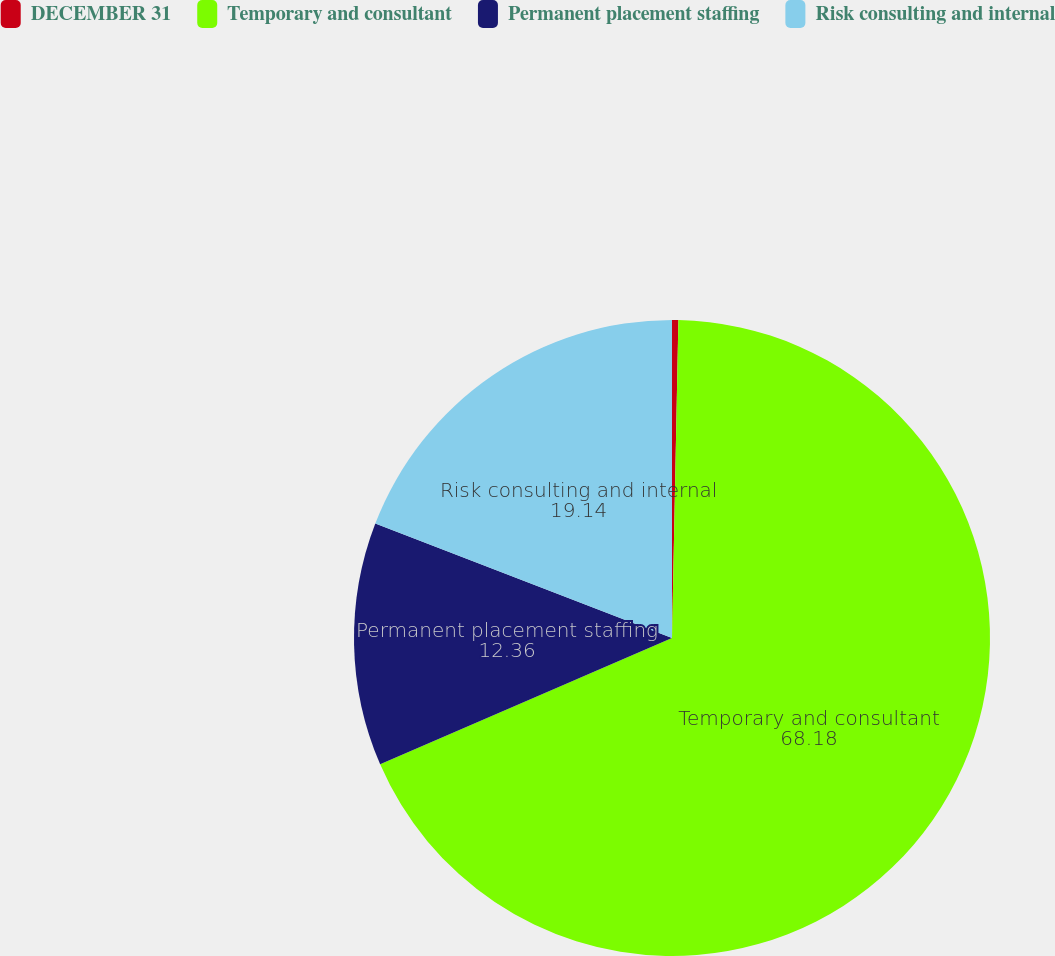Convert chart. <chart><loc_0><loc_0><loc_500><loc_500><pie_chart><fcel>DECEMBER 31<fcel>Temporary and consultant<fcel>Permanent placement staffing<fcel>Risk consulting and internal<nl><fcel>0.32%<fcel>68.18%<fcel>12.36%<fcel>19.14%<nl></chart> 